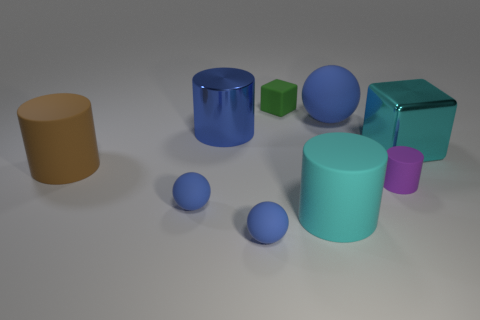Subtract all blocks. How many objects are left? 7 Subtract all matte cylinders. How many cylinders are left? 1 Subtract 3 cylinders. How many cylinders are left? 1 Subtract all brown blocks. Subtract all purple balls. How many blocks are left? 2 Subtract all cyan spheres. How many red cylinders are left? 0 Subtract all large metal cylinders. Subtract all blue cylinders. How many objects are left? 7 Add 8 cyan things. How many cyan things are left? 10 Add 9 yellow matte objects. How many yellow matte objects exist? 9 Subtract all purple cylinders. How many cylinders are left? 3 Subtract 0 yellow spheres. How many objects are left? 9 